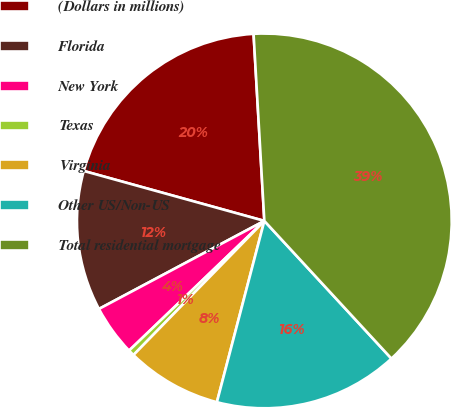Convert chart. <chart><loc_0><loc_0><loc_500><loc_500><pie_chart><fcel>(Dollars in millions)<fcel>Florida<fcel>New York<fcel>Texas<fcel>Virginia<fcel>Other US/Non-US<fcel>Total residential mortgage<nl><fcel>19.79%<fcel>12.08%<fcel>4.38%<fcel>0.53%<fcel>8.23%<fcel>15.94%<fcel>39.05%<nl></chart> 